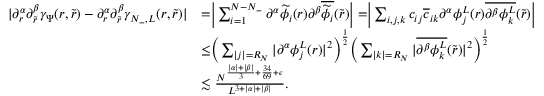<formula> <loc_0><loc_0><loc_500><loc_500>\begin{array} { r l } { | \partial _ { r } ^ { \alpha } \partial _ { \tilde { r } } ^ { \beta } \gamma _ { \Psi } ( r , \tilde { r } ) - \partial _ { r } ^ { \alpha } \partial _ { \tilde { r } } ^ { \beta } \gamma _ { N _ { - } , L } ( r , \tilde { r } ) | } & { = \left | \sum _ { i = 1 } ^ { N - N _ { - } } \partial ^ { \alpha } \widetilde { \phi _ { i } } ( r ) \partial ^ { \beta } \overline { { \widetilde { \phi } _ { i } } } ( \tilde { r } ) \right | = \left | \sum _ { i , j , k } c _ { i j } \overline { c } _ { i k } \partial ^ { \alpha } \phi _ { j } ^ { L } ( r ) \overline { { \partial ^ { \beta } \phi _ { k } ^ { L } } } ( \tilde { r } ) \right | } \\ & { \leq \left ( \sum _ { | j | = R _ { N } } | \partial ^ { \alpha } \phi _ { j } ^ { L } ( r ) | ^ { 2 } \right ) ^ { \frac { 1 } { 2 } } \left ( \sum _ { | k | = R _ { N } } | \overline { { \partial ^ { \beta } \phi _ { k } ^ { L } } } ( \tilde { r } ) | ^ { 2 } \right ) ^ { \frac { 1 } { 2 } } } \\ & { \lesssim \frac { N ^ { \frac { | \alpha | + | \beta | } { 3 } + \frac { 3 4 } { 6 9 } + \epsilon } } { L ^ { 3 + | \alpha | + | \beta | } } . } \end{array}</formula> 